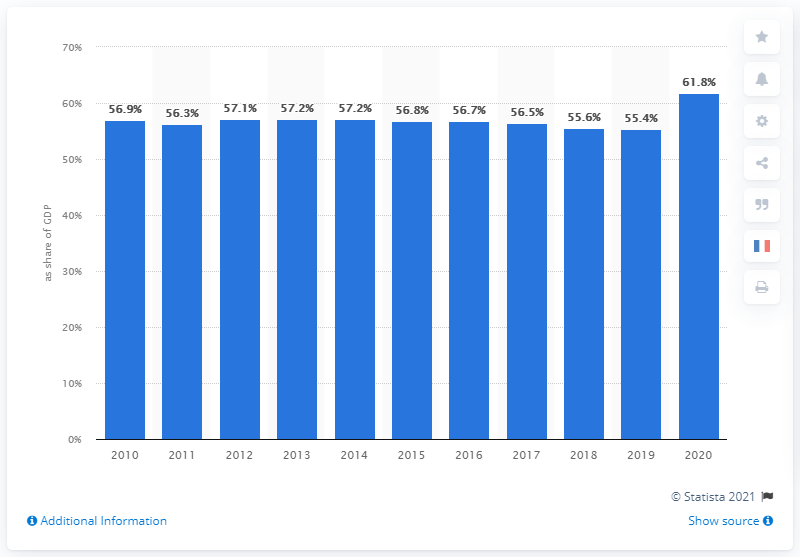Outline some significant characteristics in this image. In 2019, the French state spent 55.4% of its GDP. 